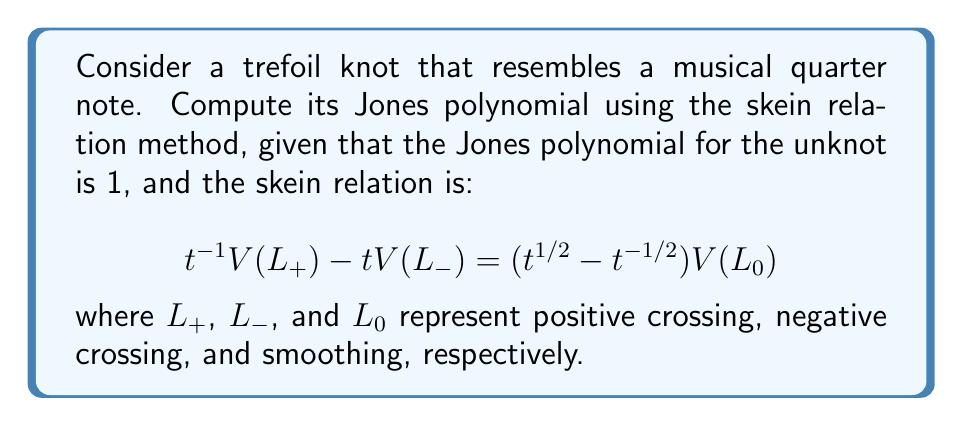Can you solve this math problem? Let's approach this step-by-step:

1) First, we need to recognize that the trefoil knot (which resembles a quarter note) has three crossings, all of which are positive.

2) We'll use the skein relation repeatedly, starting with one crossing:

   $$t^{-1}V(L_+) - tV(L_-) = (t^{1/2} - t^{-1/2})V(L_0)$$

3) $L_+$ is our trefoil knot, $L_-$ is an unknot, and $L_0$ is a Hopf link.

4) We know $V(L_-) = 1$ (unknot), so we need to find $V(L_0)$ (Hopf link).

5) For the Hopf link, applying the skein relation again:

   $$t^{-1}V(\text{Hopf}_+) - tV(\text{Hopf}_-) = (t^{1/2} - t^{-1/2})V(\text{2 unknots})$$

6) $V(\text{Hopf}_-) = 1$ (unknot), $V(\text{2 unknots}) = 1$, so:

   $$t^{-1}V(\text{Hopf}_+) - t = t^{1/2} - t^{-1/2}$$
   $$V(\text{Hopf}_+) = -t^{5/2} + t^{1/2}$$

7) Now, back to our original equation:

   $$t^{-1}V(\text{trefoil}) - t = (t^{1/2} - t^{-1/2})(-t^{5/2} + t^{1/2})$$

8) Simplifying:

   $$t^{-1}V(\text{trefoil}) = -t^3 + t + t^{-1}$$
   $$V(\text{trefoil}) = -t^4 + t^2 + 1$$

Thus, the Jones polynomial for the trefoil knot (our musical note) is $-t^4 + t^2 + 1$.
Answer: $-t^4 + t^2 + 1$ 